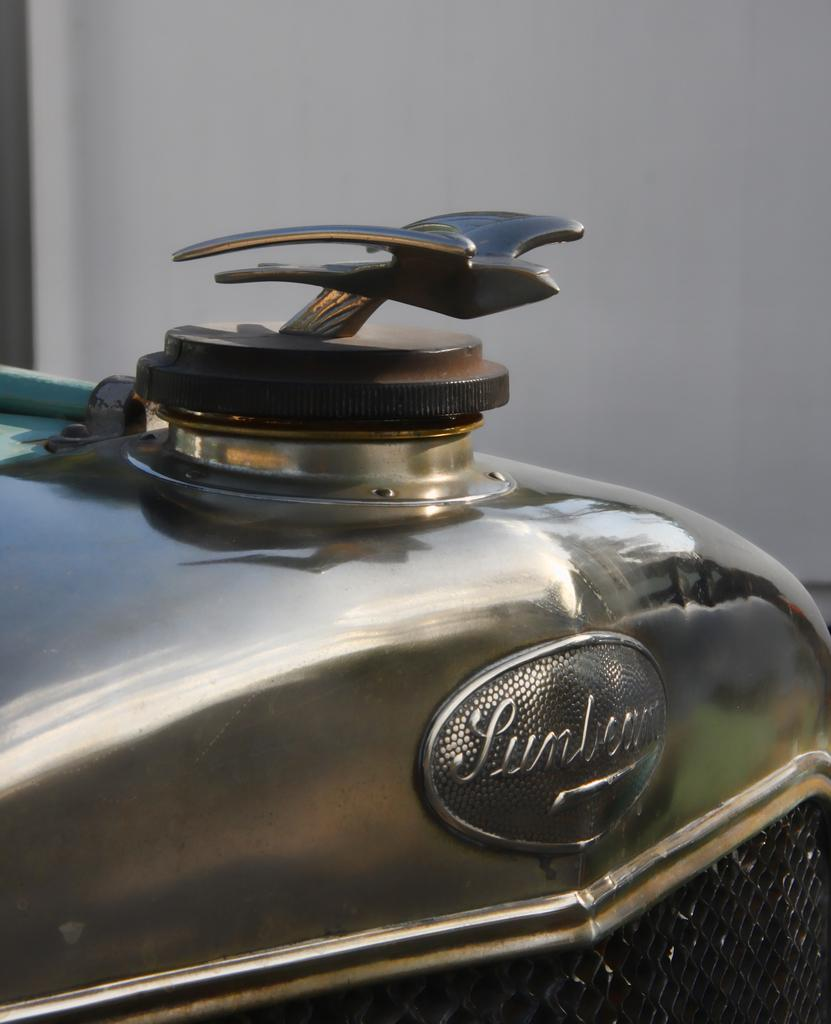What is the main subject of the image? The main subject of the image is the front part of a car. What color is the paint on the car in the image? There is no information about the color of the paint on the car in the image. What time of day is depicted in the image? There is no information about the time of day in the image. 